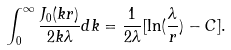<formula> <loc_0><loc_0><loc_500><loc_500>\int _ { 0 } ^ { \infty } \frac { J _ { 0 } ( k r ) } { 2 k \lambda } d k = \frac { 1 } { 2 \lambda } [ \ln ( \frac { \lambda } { r } ) - C ] .</formula> 